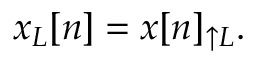<formula> <loc_0><loc_0><loc_500><loc_500>x _ { L } [ n ] = x [ n ] _ { \uparrow L } .</formula> 